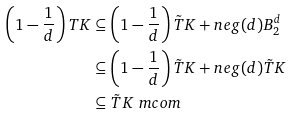Convert formula to latex. <formula><loc_0><loc_0><loc_500><loc_500>\left ( 1 - \frac { 1 } { d } \right ) T K & \subseteq \left ( 1 - \frac { 1 } { d } \right ) \tilde { T } K + n e g ( d ) B _ { 2 } ^ { d } \\ & \subseteq \left ( 1 - \frac { 1 } { d } \right ) \tilde { T } K + n e g ( d ) \tilde { T } K \\ & \subseteq \tilde { T } K \ m c o m</formula> 